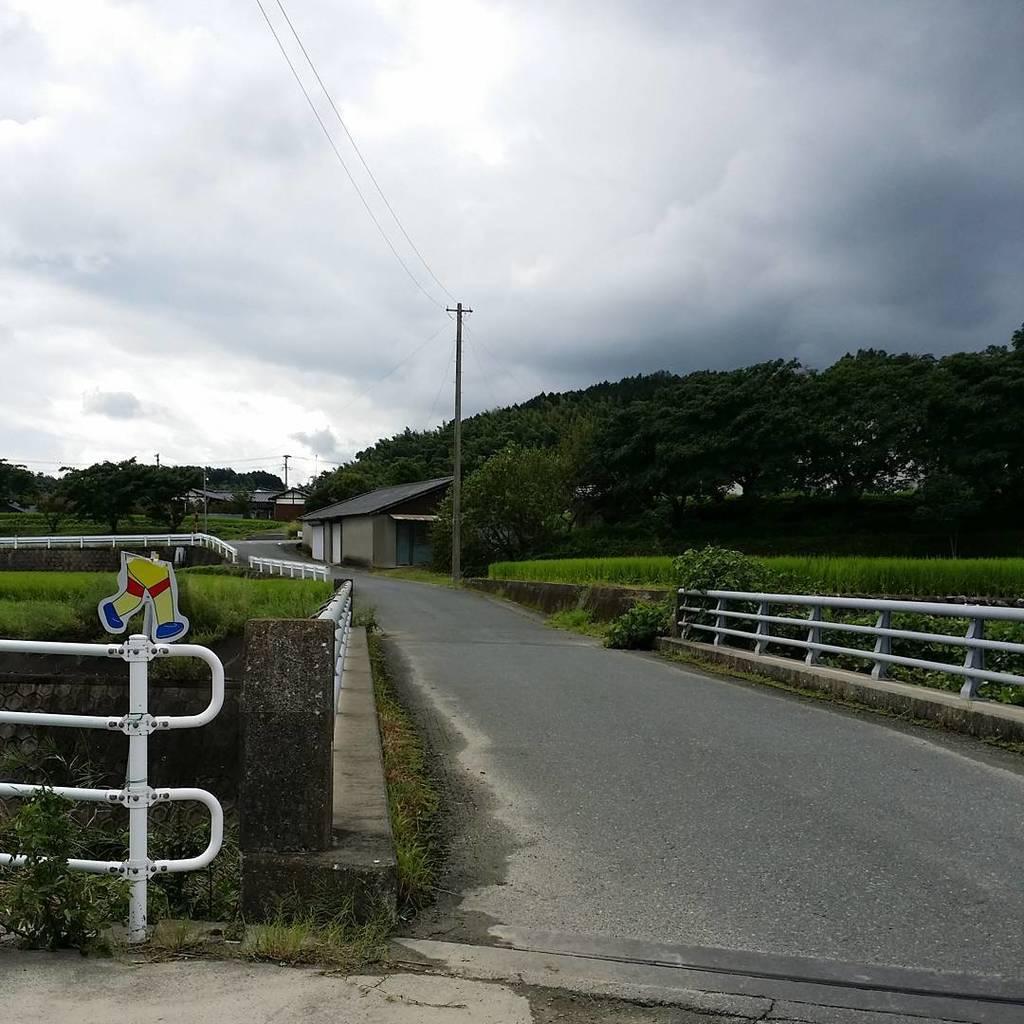How would you summarize this image in a sentence or two? In this image there is the sky towards the top of the image, there are clouds in the sky, there are houses, there are trees towards the right of the image, there are trees towards the left of the image, there are plants towards the right of the image, there are plants towards the left of the image, there is a pole, there are wires towards the top of the image, there is a road towards the bottom of the image, there is a metal fence towards the left of the image, there is a metal fence towards the right of the image. 